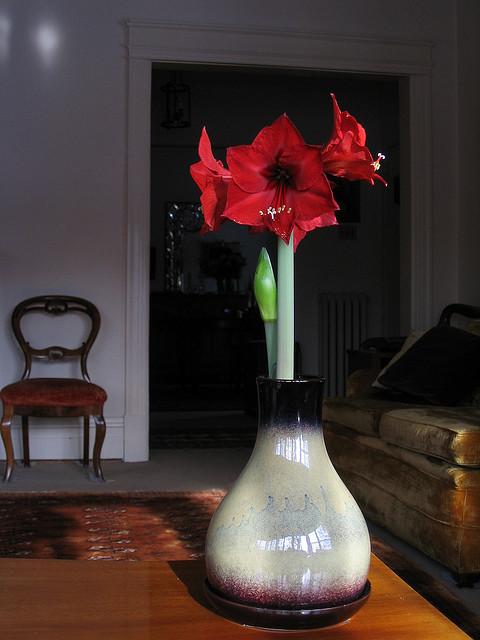What color are the stems on the flowers?
Give a very brief answer. Green. What is the flower sitting in?
Concise answer only. Vase. How many flowers are in the vase?
Write a very short answer. 3. 